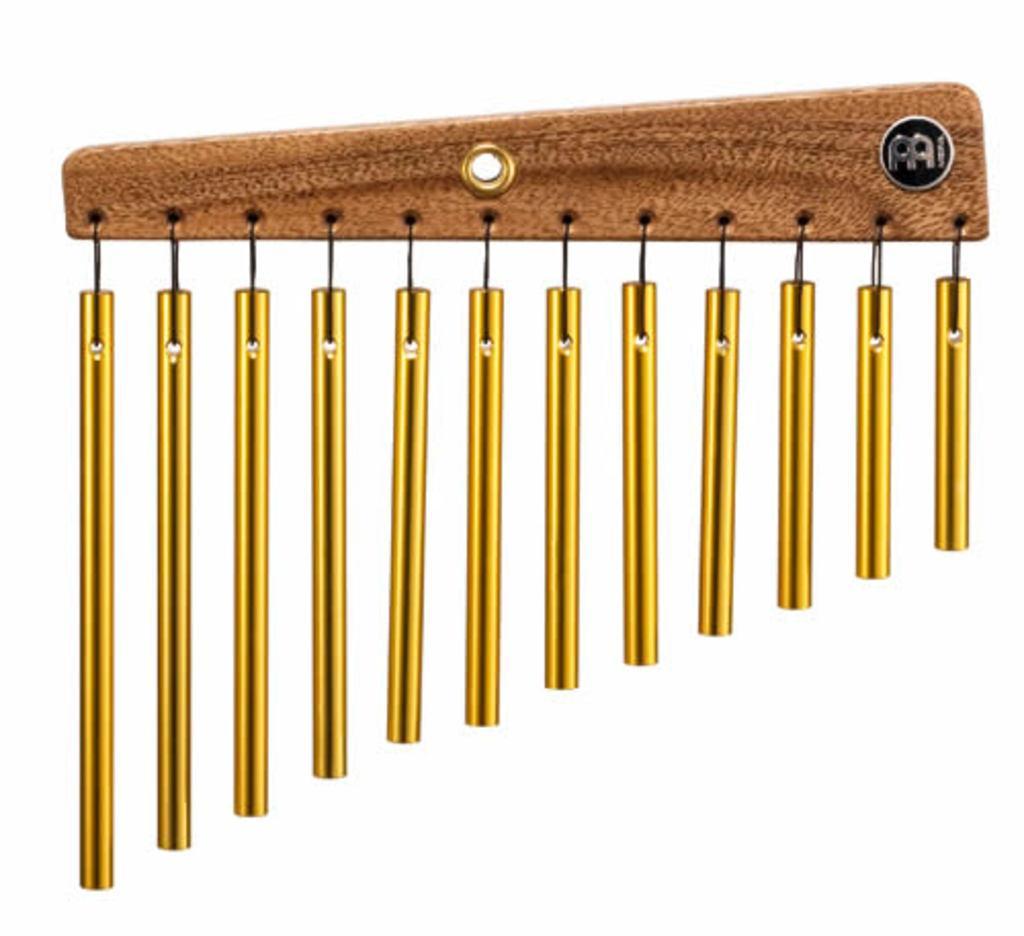How would you summarize this image in a sentence or two? In this picture we can observe gold color chimes hanged to the wooden stick. The background is in white color. 